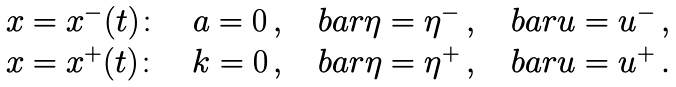Convert formula to latex. <formula><loc_0><loc_0><loc_500><loc_500>\begin{array} { l } x = x ^ { - } ( t ) \colon \quad a = 0 \, , \quad b a r \eta = \eta ^ { - } \, , \quad b a r u = u ^ { - } \, , \\ x = x ^ { + } ( t ) \colon \quad k = 0 \, , \quad b a r \eta = \eta ^ { + } \, , \quad b a r u = u ^ { + } \, . \end{array}</formula> 